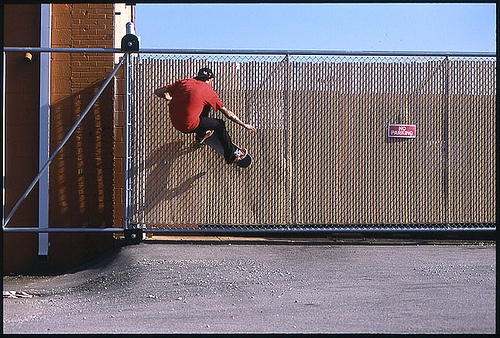Identify the text contained in this image. Parking No 